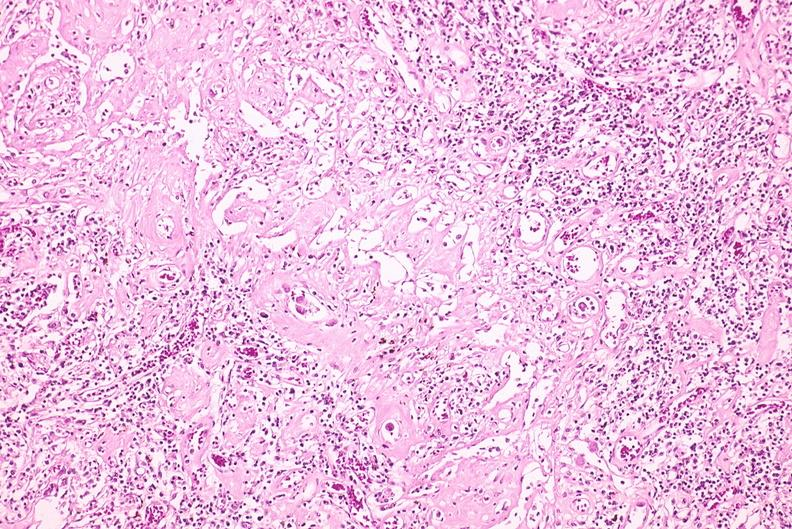what does this image show?
Answer the question using a single word or phrase. Lymph node 